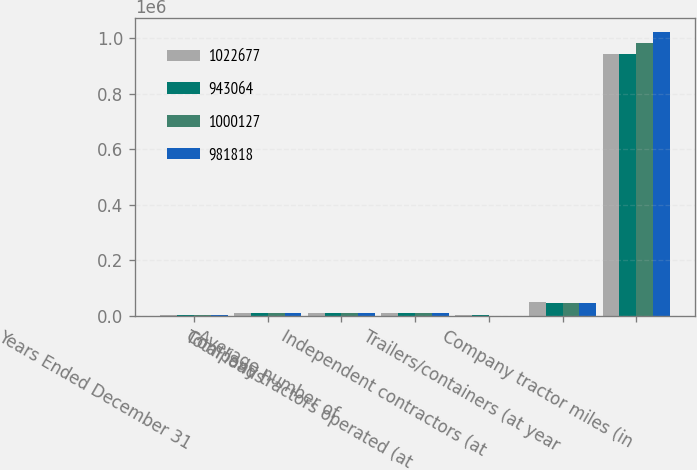<chart> <loc_0><loc_0><loc_500><loc_500><stacked_bar_chart><ecel><fcel>Years Ended December 31<fcel>Total loads<fcel>Average number of<fcel>Company tractors operated (at<fcel>Independent contractors (at<fcel>Trailers/containers (at year<fcel>Company tractor miles (in<nl><fcel>1.02268e+06<fcel>2004<fcel>10473<fcel>10042<fcel>10151<fcel>1301<fcel>48317<fcel>943064<nl><fcel>943064<fcel>2003<fcel>10473<fcel>10293<fcel>9932<fcel>994<fcel>46747<fcel>943054<nl><fcel>1.00013e+06<fcel>2002<fcel>10473<fcel>10712<fcel>10653<fcel>679<fcel>45759<fcel>981818<nl><fcel>981818<fcel>2001<fcel>10473<fcel>10710<fcel>10770<fcel>336<fcel>44318<fcel>1.02268e+06<nl></chart> 